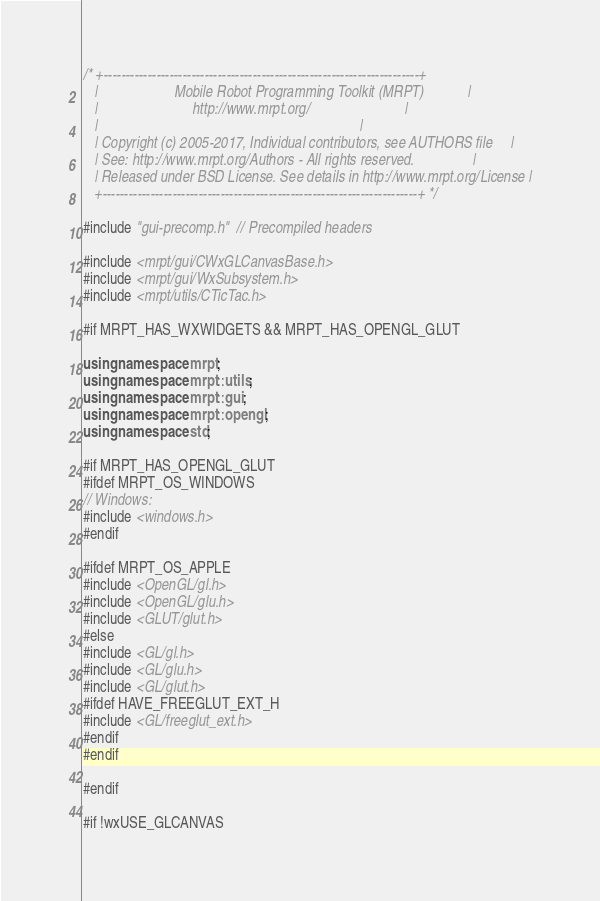<code> <loc_0><loc_0><loc_500><loc_500><_C++_>/* +------------------------------------------------------------------------+
   |                     Mobile Robot Programming Toolkit (MRPT)            |
   |                          http://www.mrpt.org/                          |
   |                                                                        |
   | Copyright (c) 2005-2017, Individual contributors, see AUTHORS file     |
   | See: http://www.mrpt.org/Authors - All rights reserved.                |
   | Released under BSD License. See details in http://www.mrpt.org/License |
   +------------------------------------------------------------------------+ */

#include "gui-precomp.h"  // Precompiled headers

#include <mrpt/gui/CWxGLCanvasBase.h>
#include <mrpt/gui/WxSubsystem.h>
#include <mrpt/utils/CTicTac.h>

#if MRPT_HAS_WXWIDGETS && MRPT_HAS_OPENGL_GLUT

using namespace mrpt;
using namespace mrpt::utils;
using namespace mrpt::gui;
using namespace mrpt::opengl;
using namespace std;

#if MRPT_HAS_OPENGL_GLUT
#ifdef MRPT_OS_WINDOWS
// Windows:
#include <windows.h>
#endif

#ifdef MRPT_OS_APPLE
#include <OpenGL/gl.h>
#include <OpenGL/glu.h>
#include <GLUT/glut.h>
#else
#include <GL/gl.h>
#include <GL/glu.h>
#include <GL/glut.h>
#ifdef HAVE_FREEGLUT_EXT_H
#include <GL/freeglut_ext.h>
#endif
#endif

#endif

#if !wxUSE_GLCANVAS</code> 